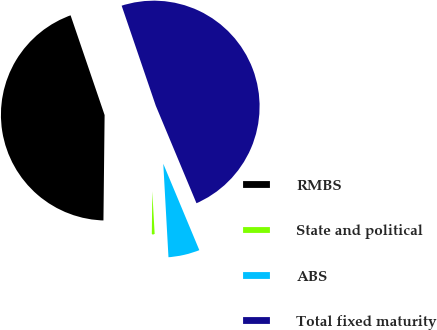Convert chart to OTSL. <chart><loc_0><loc_0><loc_500><loc_500><pie_chart><fcel>RMBS<fcel>State and political<fcel>ABS<fcel>Total fixed maturity<nl><fcel>44.59%<fcel>1.06%<fcel>5.41%<fcel>48.94%<nl></chart> 